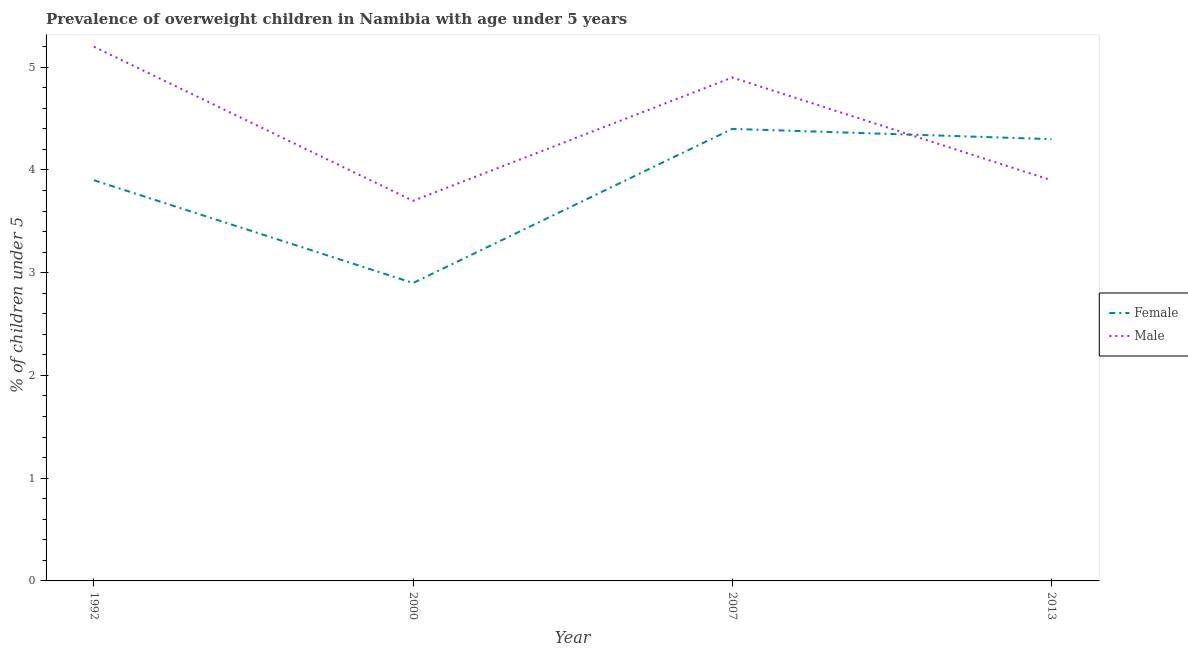How many different coloured lines are there?
Ensure brevity in your answer.  2. What is the percentage of obese female children in 2007?
Offer a terse response. 4.4. Across all years, what is the maximum percentage of obese male children?
Ensure brevity in your answer.  5.2. Across all years, what is the minimum percentage of obese female children?
Make the answer very short. 2.9. In which year was the percentage of obese male children maximum?
Give a very brief answer. 1992. In which year was the percentage of obese male children minimum?
Your answer should be very brief. 2000. What is the total percentage of obese male children in the graph?
Give a very brief answer. 17.7. What is the difference between the percentage of obese female children in 2007 and that in 2013?
Provide a short and direct response. 0.1. What is the difference between the percentage of obese male children in 2013 and the percentage of obese female children in 2000?
Offer a very short reply. 1. What is the average percentage of obese male children per year?
Provide a short and direct response. 4.43. In the year 1992, what is the difference between the percentage of obese male children and percentage of obese female children?
Offer a terse response. 1.3. In how many years, is the percentage of obese female children greater than 1 %?
Offer a terse response. 4. What is the ratio of the percentage of obese female children in 1992 to that in 2000?
Make the answer very short. 1.34. Is the percentage of obese female children in 1992 less than that in 2007?
Your response must be concise. Yes. What is the difference between the highest and the second highest percentage of obese male children?
Make the answer very short. 0.3. What is the difference between the highest and the lowest percentage of obese male children?
Your answer should be very brief. 1.5. Is the sum of the percentage of obese female children in 2007 and 2013 greater than the maximum percentage of obese male children across all years?
Provide a succinct answer. Yes. Is the percentage of obese female children strictly less than the percentage of obese male children over the years?
Offer a terse response. No. How many lines are there?
Give a very brief answer. 2. How many years are there in the graph?
Offer a very short reply. 4. Are the values on the major ticks of Y-axis written in scientific E-notation?
Your answer should be compact. No. Does the graph contain any zero values?
Ensure brevity in your answer.  No. Does the graph contain grids?
Keep it short and to the point. No. Where does the legend appear in the graph?
Make the answer very short. Center right. How are the legend labels stacked?
Your answer should be very brief. Vertical. What is the title of the graph?
Provide a succinct answer. Prevalence of overweight children in Namibia with age under 5 years. Does "UN agencies" appear as one of the legend labels in the graph?
Offer a very short reply. No. What is the label or title of the X-axis?
Offer a terse response. Year. What is the label or title of the Y-axis?
Make the answer very short.  % of children under 5. What is the  % of children under 5 of Female in 1992?
Keep it short and to the point. 3.9. What is the  % of children under 5 of Male in 1992?
Your response must be concise. 5.2. What is the  % of children under 5 in Female in 2000?
Provide a succinct answer. 2.9. What is the  % of children under 5 of Male in 2000?
Your response must be concise. 3.7. What is the  % of children under 5 in Female in 2007?
Give a very brief answer. 4.4. What is the  % of children under 5 in Male in 2007?
Keep it short and to the point. 4.9. What is the  % of children under 5 of Female in 2013?
Offer a terse response. 4.3. What is the  % of children under 5 of Male in 2013?
Make the answer very short. 3.9. Across all years, what is the maximum  % of children under 5 in Female?
Your response must be concise. 4.4. Across all years, what is the maximum  % of children under 5 of Male?
Offer a terse response. 5.2. Across all years, what is the minimum  % of children under 5 of Female?
Keep it short and to the point. 2.9. Across all years, what is the minimum  % of children under 5 of Male?
Keep it short and to the point. 3.7. What is the total  % of children under 5 in Female in the graph?
Provide a succinct answer. 15.5. What is the difference between the  % of children under 5 of Female in 1992 and that in 2000?
Provide a succinct answer. 1. What is the difference between the  % of children under 5 of Male in 1992 and that in 2000?
Ensure brevity in your answer.  1.5. What is the difference between the  % of children under 5 in Male in 1992 and that in 2013?
Provide a short and direct response. 1.3. What is the difference between the  % of children under 5 of Female in 2000 and that in 2007?
Your answer should be very brief. -1.5. What is the difference between the  % of children under 5 of Female in 2000 and that in 2013?
Offer a terse response. -1.4. What is the difference between the  % of children under 5 of Female in 1992 and the  % of children under 5 of Male in 2000?
Offer a terse response. 0.2. What is the difference between the  % of children under 5 in Female in 1992 and the  % of children under 5 in Male in 2013?
Ensure brevity in your answer.  0. What is the difference between the  % of children under 5 of Female in 2000 and the  % of children under 5 of Male in 2007?
Your response must be concise. -2. What is the difference between the  % of children under 5 in Female in 2007 and the  % of children under 5 in Male in 2013?
Ensure brevity in your answer.  0.5. What is the average  % of children under 5 in Female per year?
Your answer should be compact. 3.88. What is the average  % of children under 5 in Male per year?
Your answer should be compact. 4.42. In the year 1992, what is the difference between the  % of children under 5 of Female and  % of children under 5 of Male?
Offer a very short reply. -1.3. In the year 2007, what is the difference between the  % of children under 5 in Female and  % of children under 5 in Male?
Your answer should be very brief. -0.5. What is the ratio of the  % of children under 5 in Female in 1992 to that in 2000?
Give a very brief answer. 1.34. What is the ratio of the  % of children under 5 of Male in 1992 to that in 2000?
Provide a short and direct response. 1.41. What is the ratio of the  % of children under 5 in Female in 1992 to that in 2007?
Provide a short and direct response. 0.89. What is the ratio of the  % of children under 5 in Male in 1992 to that in 2007?
Provide a short and direct response. 1.06. What is the ratio of the  % of children under 5 of Female in 1992 to that in 2013?
Make the answer very short. 0.91. What is the ratio of the  % of children under 5 of Female in 2000 to that in 2007?
Your answer should be compact. 0.66. What is the ratio of the  % of children under 5 in Male in 2000 to that in 2007?
Keep it short and to the point. 0.76. What is the ratio of the  % of children under 5 in Female in 2000 to that in 2013?
Keep it short and to the point. 0.67. What is the ratio of the  % of children under 5 in Male in 2000 to that in 2013?
Keep it short and to the point. 0.95. What is the ratio of the  % of children under 5 in Female in 2007 to that in 2013?
Your answer should be compact. 1.02. What is the ratio of the  % of children under 5 in Male in 2007 to that in 2013?
Your response must be concise. 1.26. What is the difference between the highest and the lowest  % of children under 5 of Female?
Keep it short and to the point. 1.5. What is the difference between the highest and the lowest  % of children under 5 of Male?
Your answer should be compact. 1.5. 